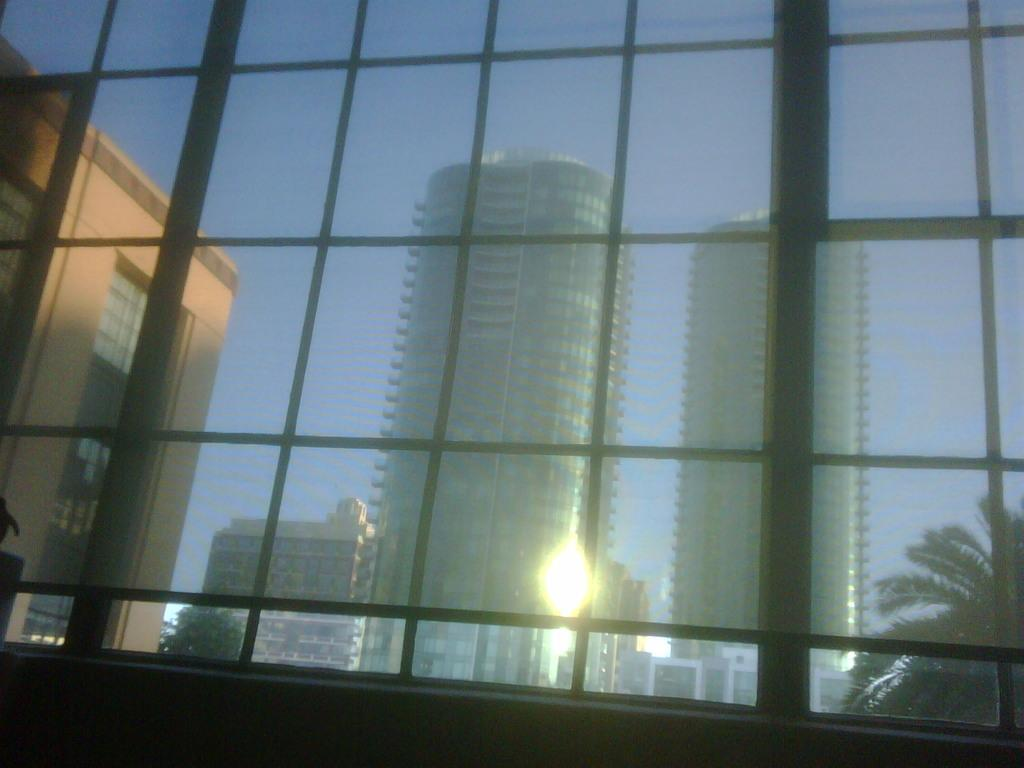What is located in the foreground of the image? There is a window in the foreground of the image. What can be seen through the window? Buildings and trees are visible behind the window. Can you describe the background of the image? The background of the image consists of buildings and trees. How many buns are being held by the passenger in the image? There is no passenger present in the image, and therefore no buns can be held by anyone. 